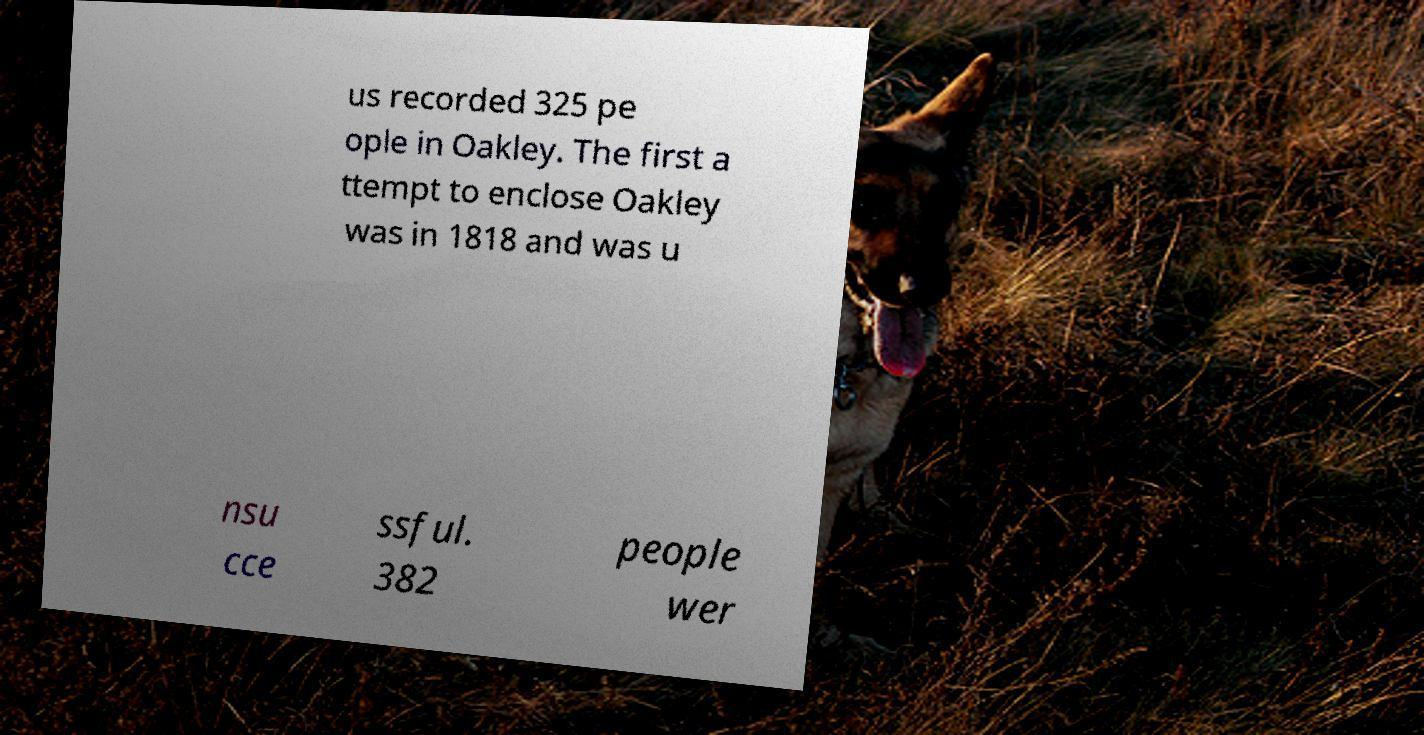For documentation purposes, I need the text within this image transcribed. Could you provide that? us recorded 325 pe ople in Oakley. The first a ttempt to enclose Oakley was in 1818 and was u nsu cce ssful. 382 people wer 